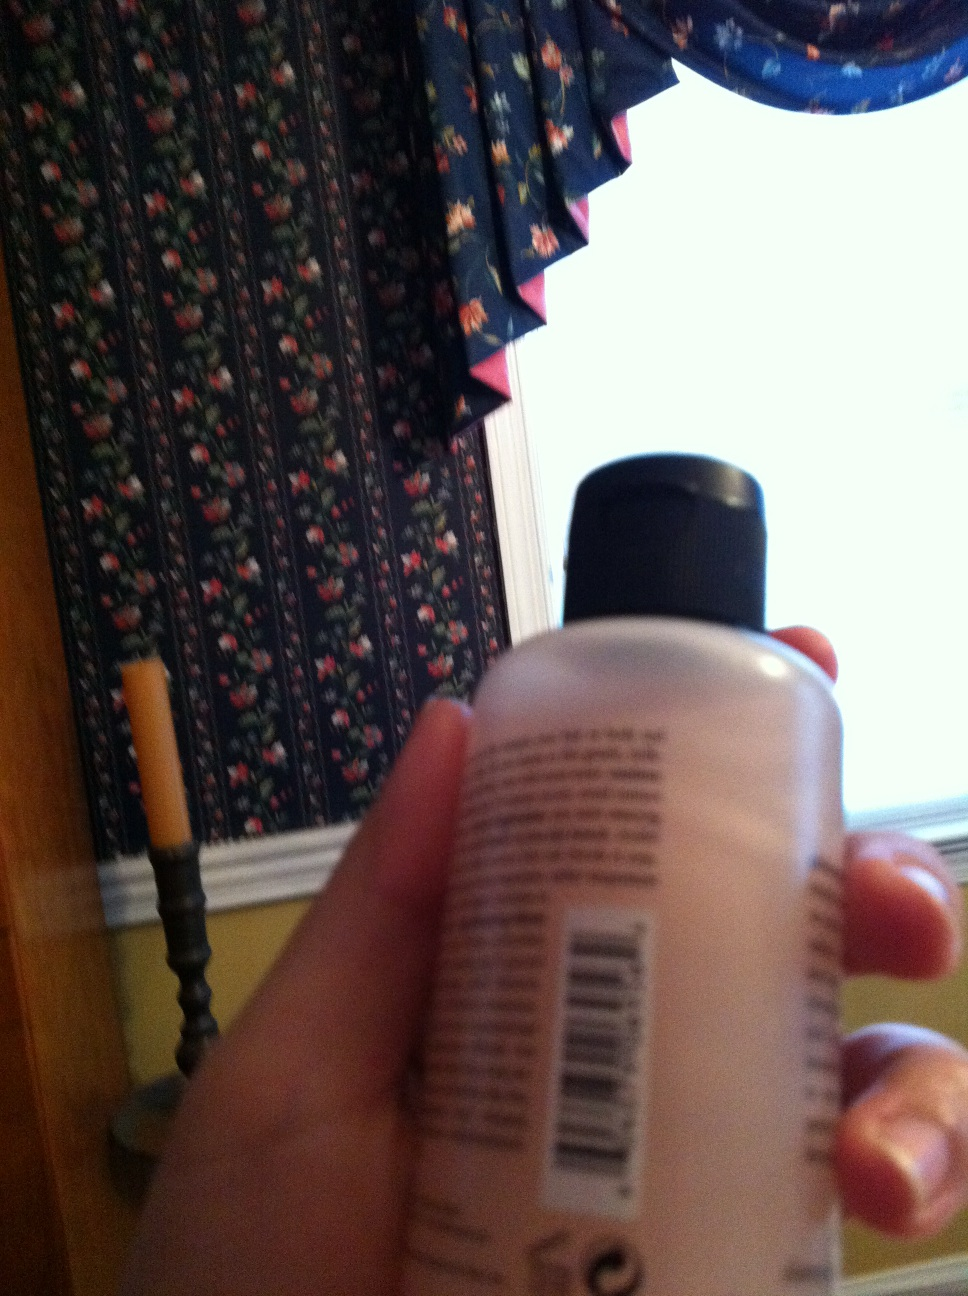Provide a creative question for this image. If this bottle could talk, what stories and secrets do you think it would share about the places it has been and the people who have used it? 